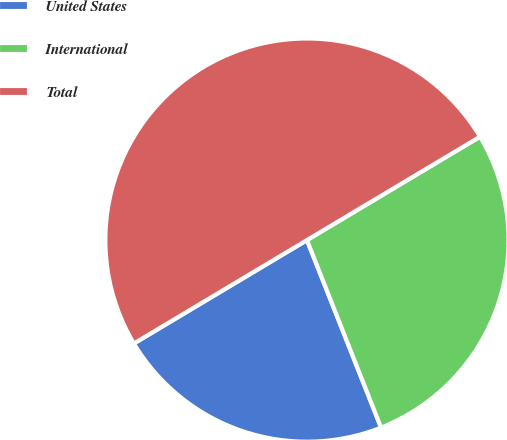<chart> <loc_0><loc_0><loc_500><loc_500><pie_chart><fcel>United States<fcel>International<fcel>Total<nl><fcel>22.42%<fcel>27.58%<fcel>50.0%<nl></chart> 